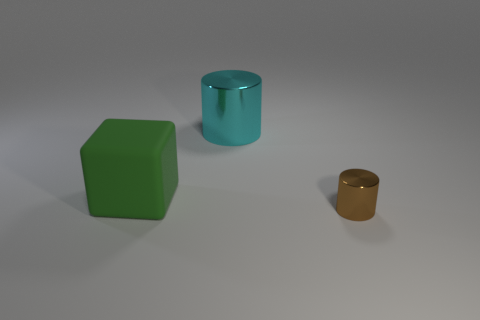Add 2 big blue balls. How many objects exist? 5 Subtract all cubes. How many objects are left? 2 Subtract 0 yellow cubes. How many objects are left? 3 Subtract all tiny brown things. Subtract all small metallic objects. How many objects are left? 1 Add 3 green cubes. How many green cubes are left? 4 Add 3 brown shiny things. How many brown shiny things exist? 4 